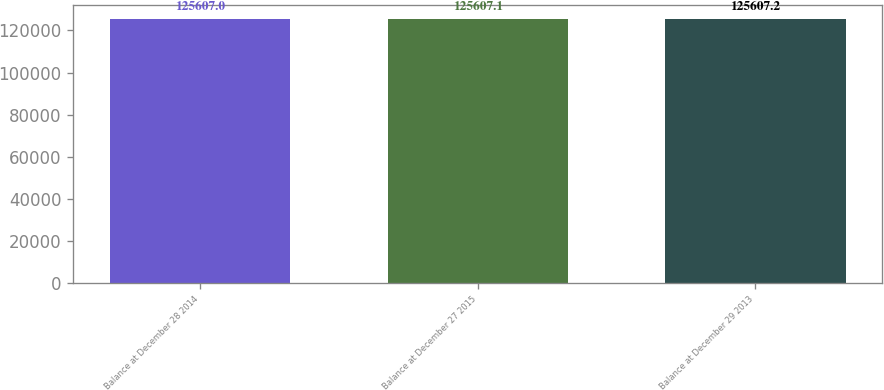Convert chart to OTSL. <chart><loc_0><loc_0><loc_500><loc_500><bar_chart><fcel>Balance at December 28 2014<fcel>Balance at December 27 2015<fcel>Balance at December 29 2013<nl><fcel>125607<fcel>125607<fcel>125607<nl></chart> 